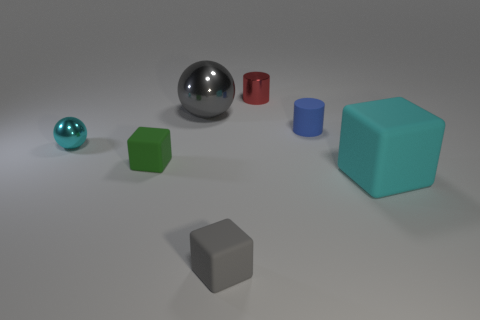Add 1 gray matte cubes. How many objects exist? 8 Subtract all cylinders. How many objects are left? 5 Subtract all large objects. Subtract all cyan metal balls. How many objects are left? 4 Add 7 small cubes. How many small cubes are left? 9 Add 1 big cyan rubber things. How many big cyan rubber things exist? 2 Subtract 0 brown cylinders. How many objects are left? 7 